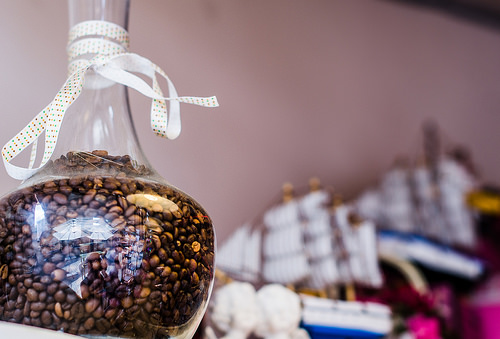<image>
Is there a boat behind the beans? Yes. From this viewpoint, the boat is positioned behind the beans, with the beans partially or fully occluding the boat. 